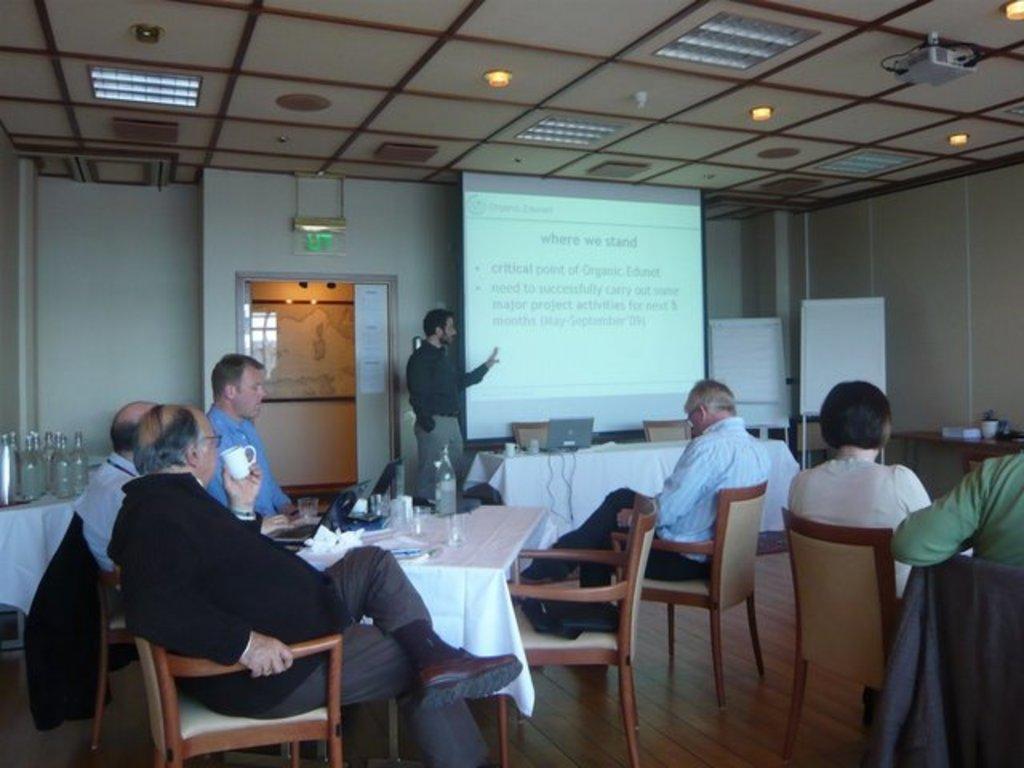Can you describe this image briefly? In this picture there are several people sat on chair and there is a guy in front wearing a black shirt explaining the screen and there are some whiteboards beside the screen and over the ceiling there are several lights and this seems to be of meeting room, and there is table at left side corner with some bottles on it and there is a entrance door in the middle of the room. 